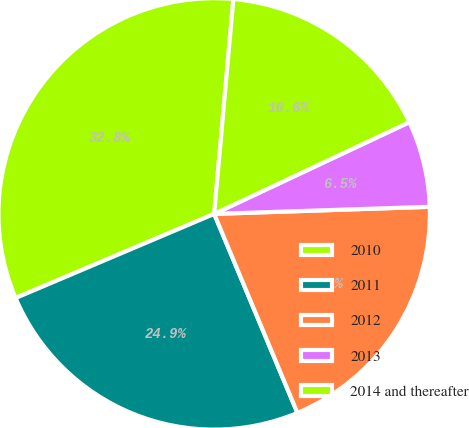Convert chart. <chart><loc_0><loc_0><loc_500><loc_500><pie_chart><fcel>2010<fcel>2011<fcel>2012<fcel>2013<fcel>2014 and thereafter<nl><fcel>32.8%<fcel>24.93%<fcel>19.22%<fcel>6.47%<fcel>16.59%<nl></chart> 